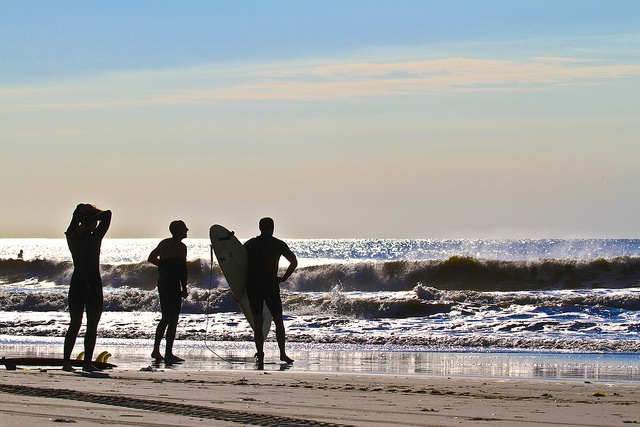Describe the objects in this image and their specific colors. I can see people in lightblue, black, lightgray, gray, and darkgray tones, people in lightblue, black, gray, ivory, and maroon tones, people in lightblue, black, lightgray, darkgray, and gray tones, surfboard in lightblue, black, lightgray, darkgray, and gray tones, and surfboard in lightblue, black, darkgray, maroon, and gray tones in this image. 